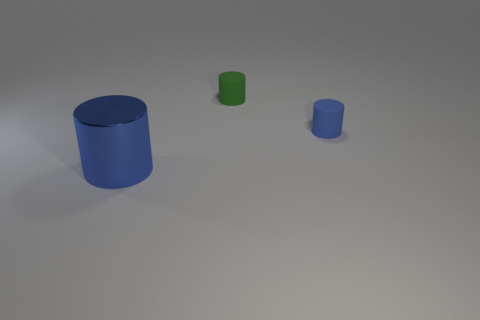Add 2 metallic objects. How many objects exist? 5 Add 2 small blue matte cylinders. How many small blue matte cylinders exist? 3 Subtract 0 cyan cylinders. How many objects are left? 3 Subtract all small cyan rubber blocks. Subtract all big shiny things. How many objects are left? 2 Add 2 tiny rubber things. How many tiny rubber things are left? 4 